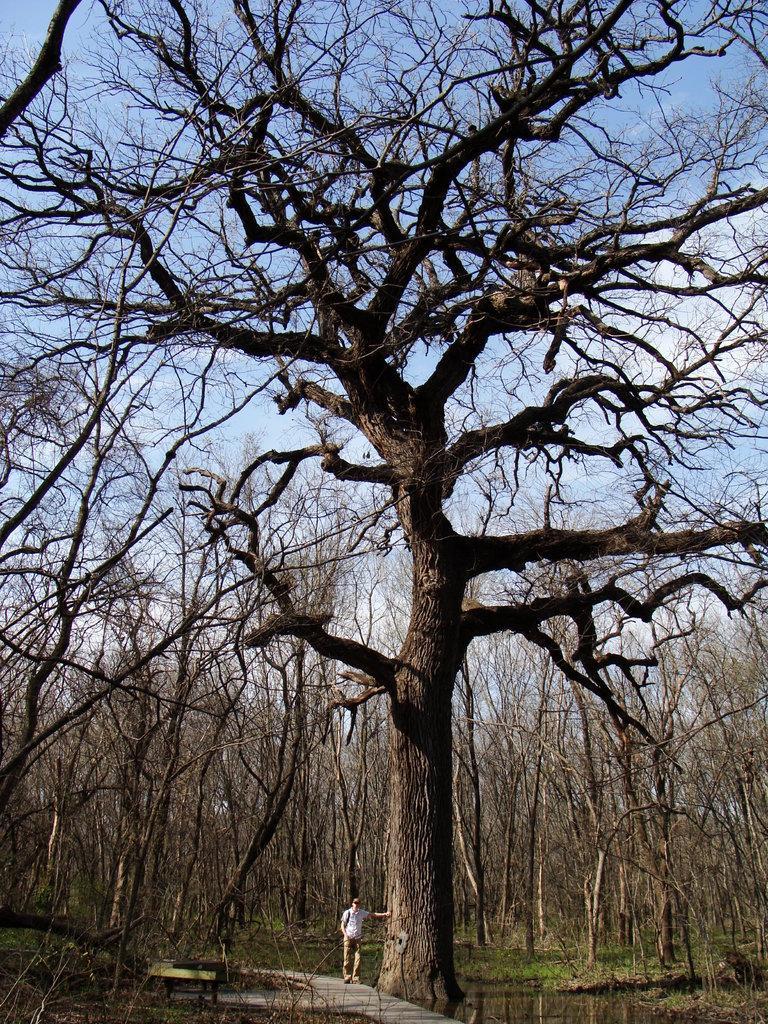Describe this image in one or two sentences. In this image we can see some trees and there is a man standing near the tree and we can see the sky in the background. 